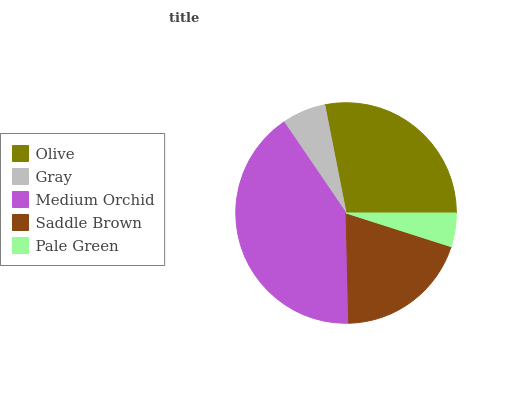Is Pale Green the minimum?
Answer yes or no. Yes. Is Medium Orchid the maximum?
Answer yes or no. Yes. Is Gray the minimum?
Answer yes or no. No. Is Gray the maximum?
Answer yes or no. No. Is Olive greater than Gray?
Answer yes or no. Yes. Is Gray less than Olive?
Answer yes or no. Yes. Is Gray greater than Olive?
Answer yes or no. No. Is Olive less than Gray?
Answer yes or no. No. Is Saddle Brown the high median?
Answer yes or no. Yes. Is Saddle Brown the low median?
Answer yes or no. Yes. Is Olive the high median?
Answer yes or no. No. Is Medium Orchid the low median?
Answer yes or no. No. 